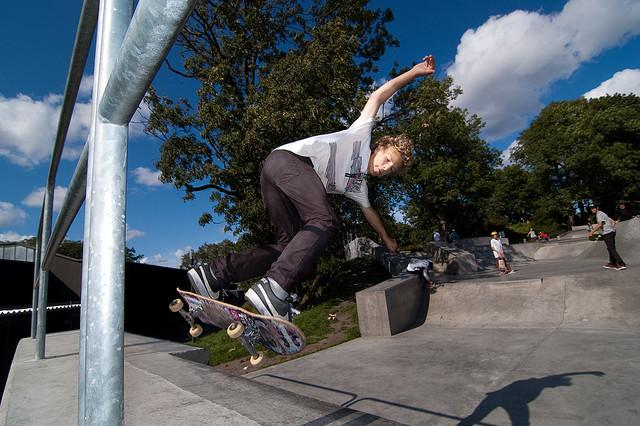What will happen to the boy next? Please explain your reasoning. landing. He will land from his stunt. 